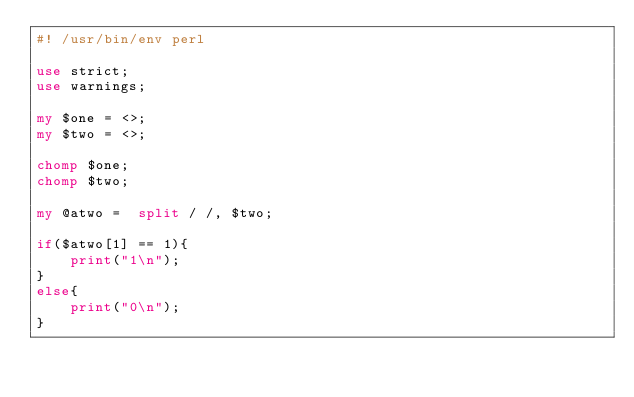Convert code to text. <code><loc_0><loc_0><loc_500><loc_500><_Perl_>#! /usr/bin/env perl

use strict;
use warnings;

my $one = <>;
my $two = <>;

chomp $one;
chomp $two;

my @atwo =  split / /, $two;

if($atwo[1] == 1){
    print("1\n");
}
else{
    print("0\n");
}</code> 